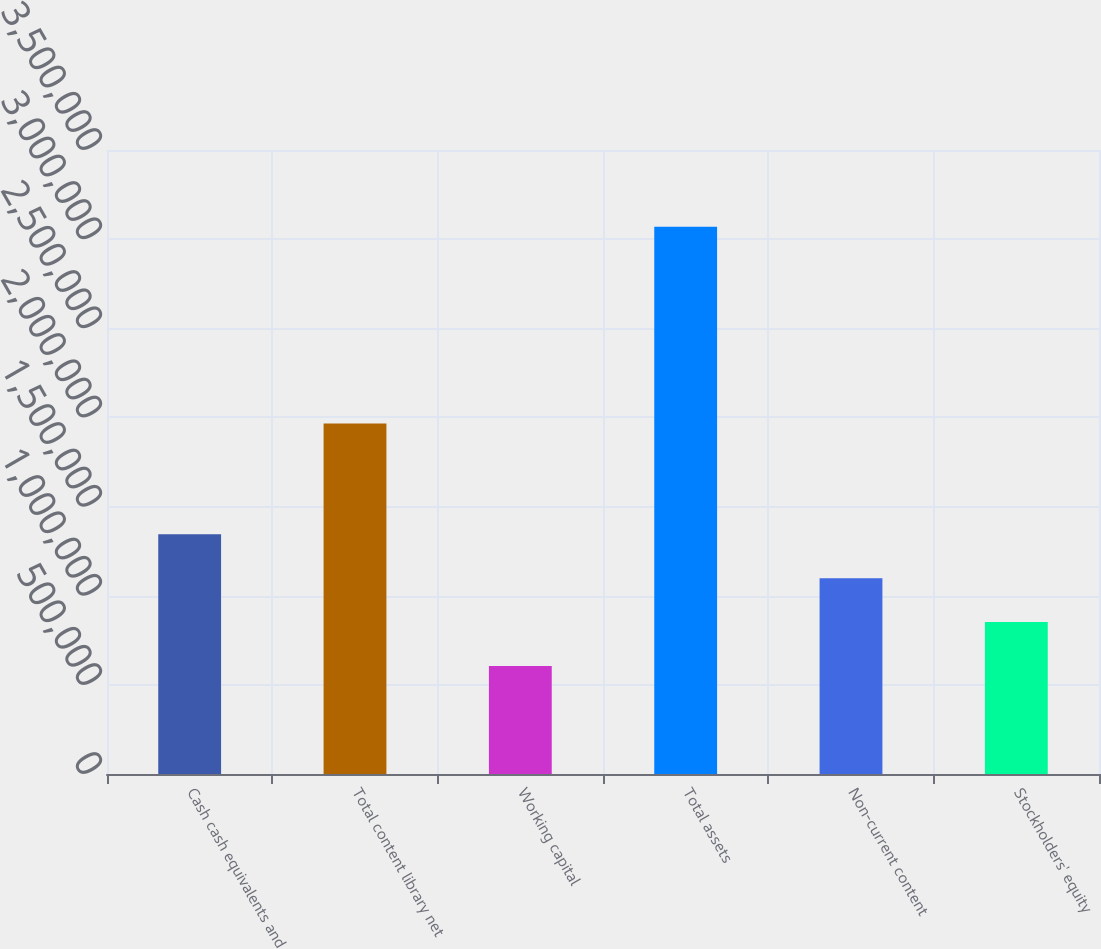<chart> <loc_0><loc_0><loc_500><loc_500><bar_chart><fcel>Cash cash equivalents and<fcel>Total content library net<fcel>Working capital<fcel>Total assets<fcel>Non-current content<fcel>Stockholders' equity<nl><fcel>1.34482e+06<fcel>1.96664e+06<fcel>605802<fcel>3.0692e+06<fcel>1.09848e+06<fcel>852141<nl></chart> 